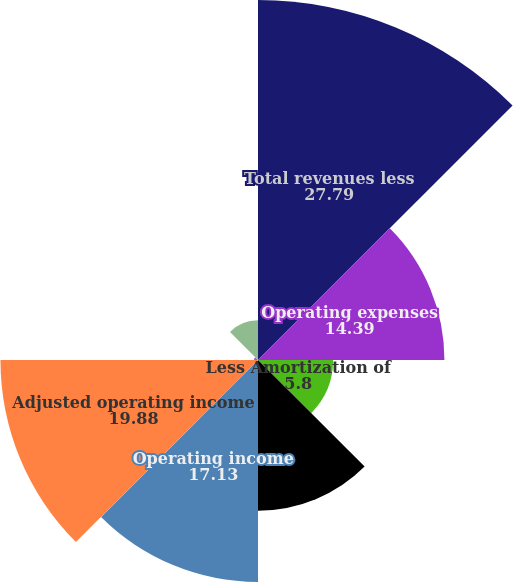Convert chart to OTSL. <chart><loc_0><loc_0><loc_500><loc_500><pie_chart><fcel>Total revenues less<fcel>Operating expenses<fcel>Less Amortization of<fcel>Adjusted operating expenses<fcel>Operating income<fcel>Adjusted operating income<fcel>Operating margin<fcel>Adjusted operating margin<nl><fcel>27.79%<fcel>14.39%<fcel>5.8%<fcel>11.64%<fcel>17.13%<fcel>19.88%<fcel>0.31%<fcel>3.06%<nl></chart> 